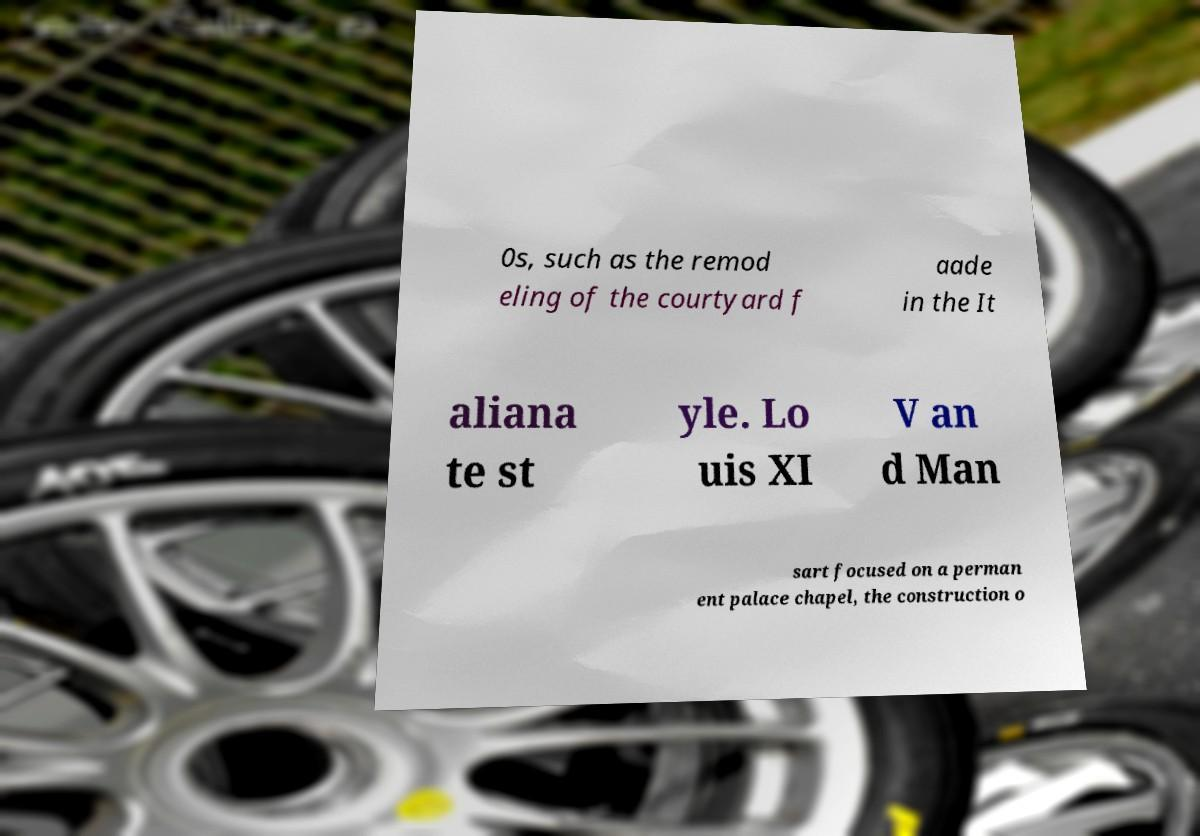Can you read and provide the text displayed in the image?This photo seems to have some interesting text. Can you extract and type it out for me? 0s, such as the remod eling of the courtyard f aade in the It aliana te st yle. Lo uis XI V an d Man sart focused on a perman ent palace chapel, the construction o 